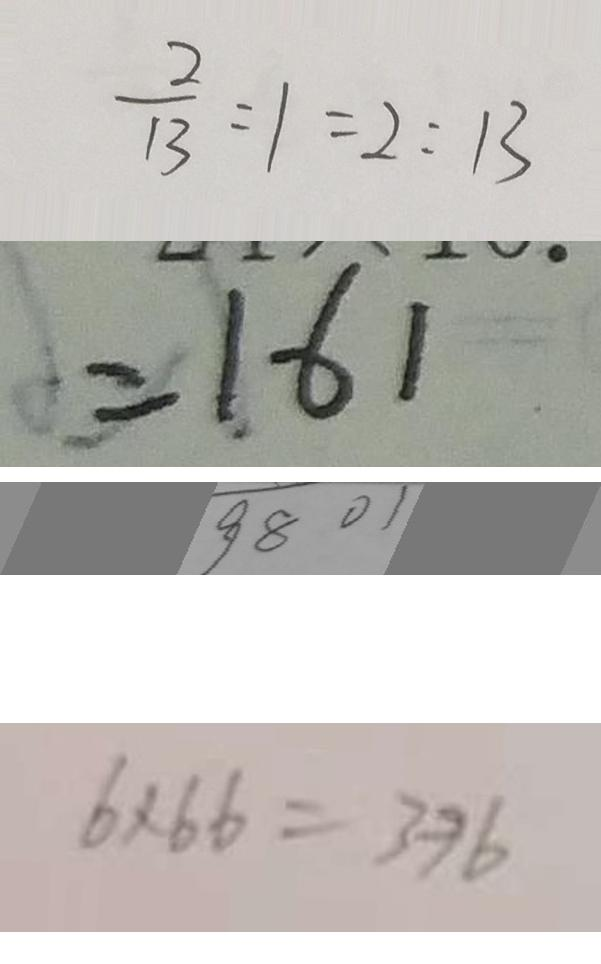Convert formula to latex. <formula><loc_0><loc_0><loc_500><loc_500>\frac { 2 } { 1 3 } : 1 = 2 : 1 3 
 = 1 6 1 
 9 8 0 1 
 6 \times 6 6 = 3 9 6</formula> 